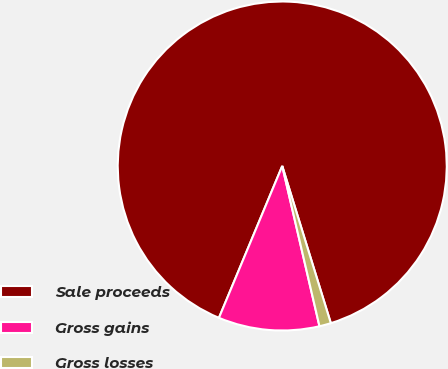Convert chart to OTSL. <chart><loc_0><loc_0><loc_500><loc_500><pie_chart><fcel>Sale proceeds<fcel>Gross gains<fcel>Gross losses<nl><fcel>88.94%<fcel>9.92%<fcel>1.14%<nl></chart> 